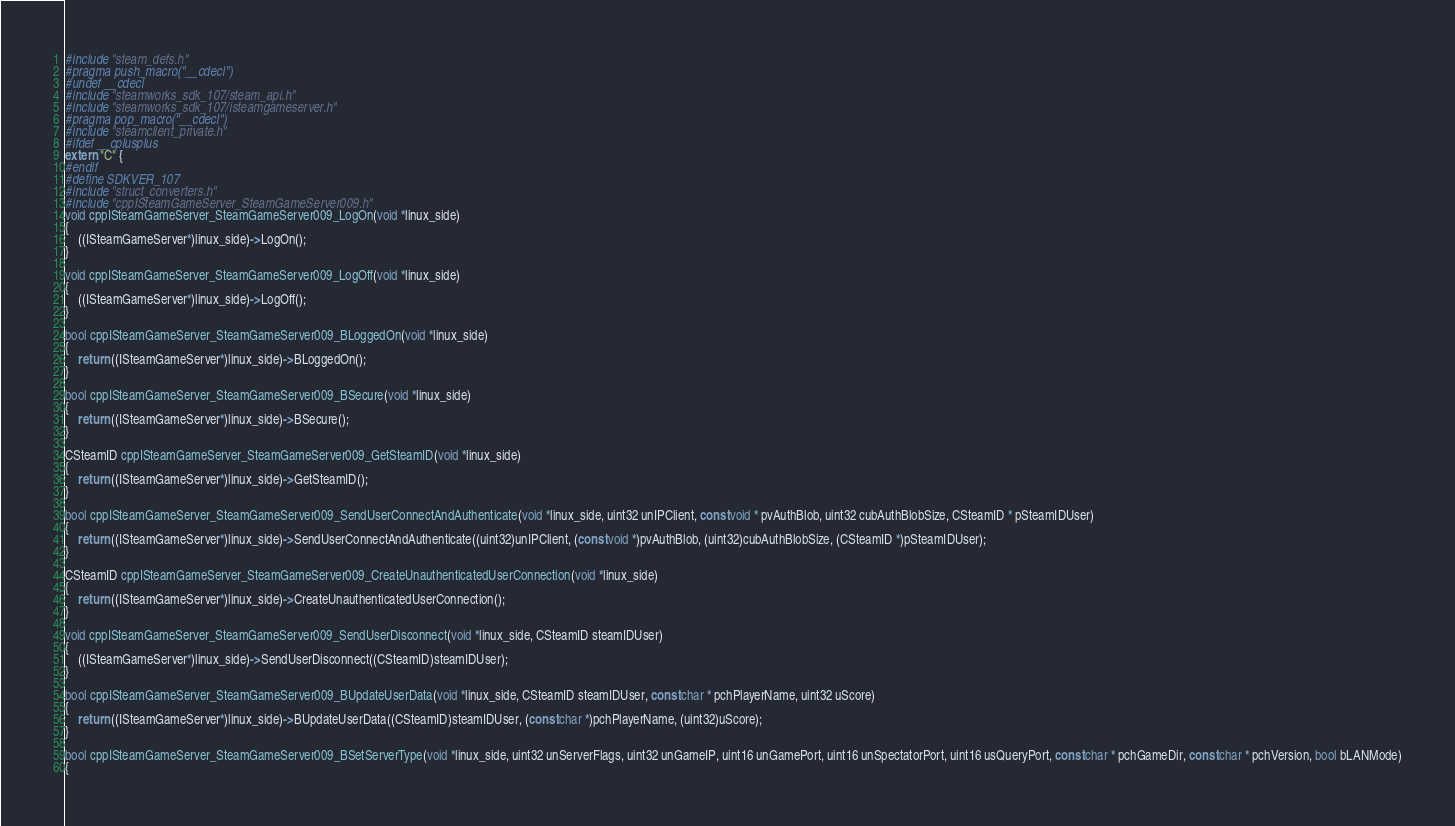<code> <loc_0><loc_0><loc_500><loc_500><_C++_>#include "steam_defs.h"
#pragma push_macro("__cdecl")
#undef __cdecl
#include "steamworks_sdk_107/steam_api.h"
#include "steamworks_sdk_107/isteamgameserver.h"
#pragma pop_macro("__cdecl")
#include "steamclient_private.h"
#ifdef __cplusplus
extern "C" {
#endif
#define SDKVER_107
#include "struct_converters.h"
#include "cppISteamGameServer_SteamGameServer009.h"
void cppISteamGameServer_SteamGameServer009_LogOn(void *linux_side)
{
    ((ISteamGameServer*)linux_side)->LogOn();
}

void cppISteamGameServer_SteamGameServer009_LogOff(void *linux_side)
{
    ((ISteamGameServer*)linux_side)->LogOff();
}

bool cppISteamGameServer_SteamGameServer009_BLoggedOn(void *linux_side)
{
    return ((ISteamGameServer*)linux_side)->BLoggedOn();
}

bool cppISteamGameServer_SteamGameServer009_BSecure(void *linux_side)
{
    return ((ISteamGameServer*)linux_side)->BSecure();
}

CSteamID cppISteamGameServer_SteamGameServer009_GetSteamID(void *linux_side)
{
    return ((ISteamGameServer*)linux_side)->GetSteamID();
}

bool cppISteamGameServer_SteamGameServer009_SendUserConnectAndAuthenticate(void *linux_side, uint32 unIPClient, const void * pvAuthBlob, uint32 cubAuthBlobSize, CSteamID * pSteamIDUser)
{
    return ((ISteamGameServer*)linux_side)->SendUserConnectAndAuthenticate((uint32)unIPClient, (const void *)pvAuthBlob, (uint32)cubAuthBlobSize, (CSteamID *)pSteamIDUser);
}

CSteamID cppISteamGameServer_SteamGameServer009_CreateUnauthenticatedUserConnection(void *linux_side)
{
    return ((ISteamGameServer*)linux_side)->CreateUnauthenticatedUserConnection();
}

void cppISteamGameServer_SteamGameServer009_SendUserDisconnect(void *linux_side, CSteamID steamIDUser)
{
    ((ISteamGameServer*)linux_side)->SendUserDisconnect((CSteamID)steamIDUser);
}

bool cppISteamGameServer_SteamGameServer009_BUpdateUserData(void *linux_side, CSteamID steamIDUser, const char * pchPlayerName, uint32 uScore)
{
    return ((ISteamGameServer*)linux_side)->BUpdateUserData((CSteamID)steamIDUser, (const char *)pchPlayerName, (uint32)uScore);
}

bool cppISteamGameServer_SteamGameServer009_BSetServerType(void *linux_side, uint32 unServerFlags, uint32 unGameIP, uint16 unGamePort, uint16 unSpectatorPort, uint16 usQueryPort, const char * pchGameDir, const char * pchVersion, bool bLANMode)
{</code> 